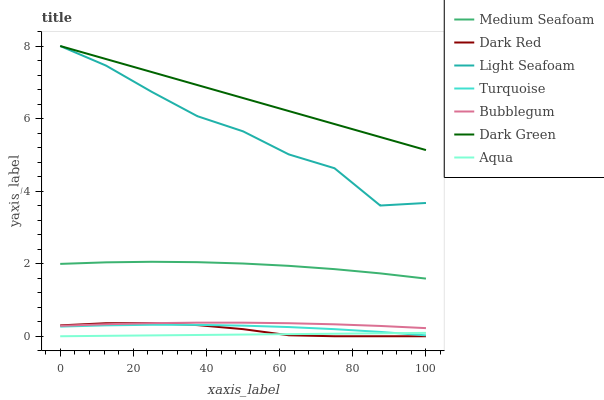Does Aqua have the minimum area under the curve?
Answer yes or no. Yes. Does Dark Green have the maximum area under the curve?
Answer yes or no. Yes. Does Dark Red have the minimum area under the curve?
Answer yes or no. No. Does Dark Red have the maximum area under the curve?
Answer yes or no. No. Is Aqua the smoothest?
Answer yes or no. Yes. Is Light Seafoam the roughest?
Answer yes or no. Yes. Is Dark Red the smoothest?
Answer yes or no. No. Is Dark Red the roughest?
Answer yes or no. No. Does Dark Red have the lowest value?
Answer yes or no. Yes. Does Bubblegum have the lowest value?
Answer yes or no. No. Does Dark Green have the highest value?
Answer yes or no. Yes. Does Dark Red have the highest value?
Answer yes or no. No. Is Medium Seafoam less than Dark Green?
Answer yes or no. Yes. Is Dark Green greater than Bubblegum?
Answer yes or no. Yes. Does Turquoise intersect Dark Red?
Answer yes or no. Yes. Is Turquoise less than Dark Red?
Answer yes or no. No. Is Turquoise greater than Dark Red?
Answer yes or no. No. Does Medium Seafoam intersect Dark Green?
Answer yes or no. No. 